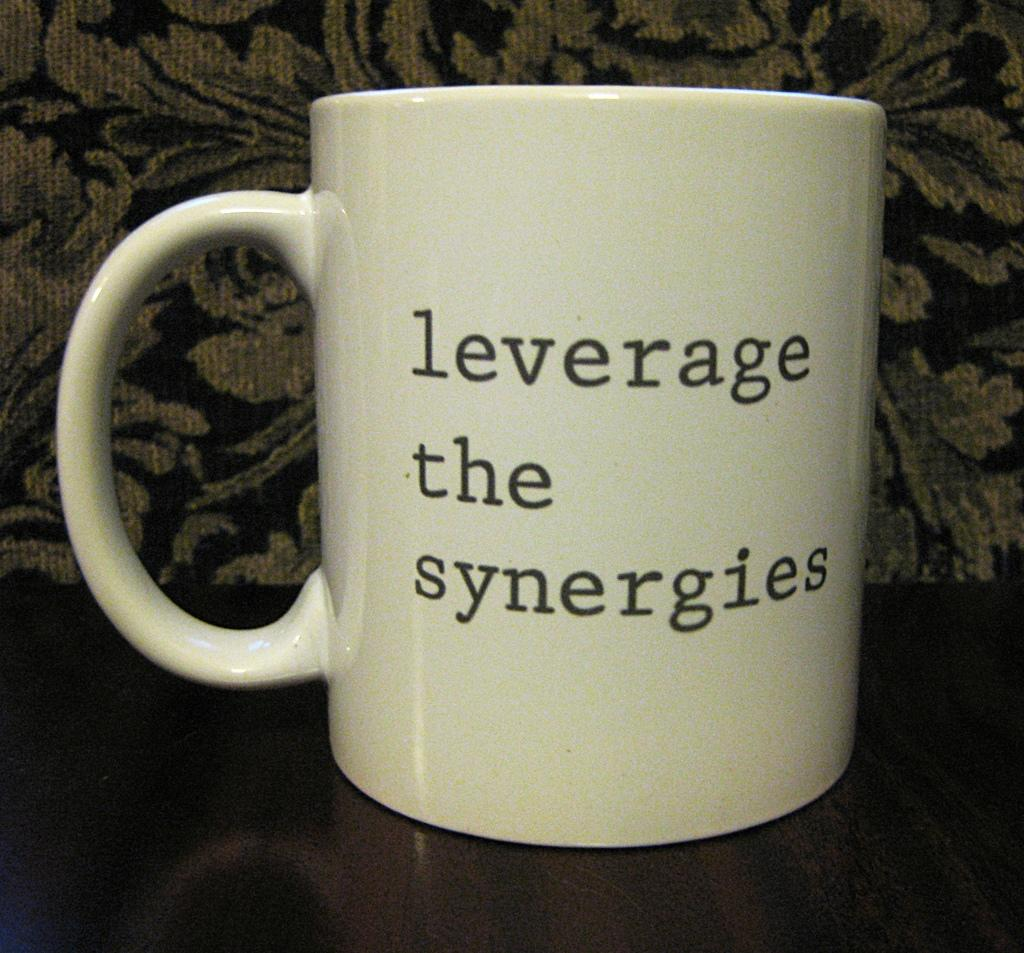<image>
Describe the image concisely. a coffee mug that says leverage the synergies 